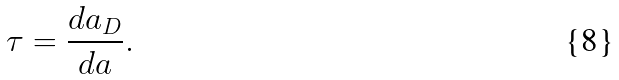<formula> <loc_0><loc_0><loc_500><loc_500>\tau = \frac { d a _ { D } } { d a } .</formula> 